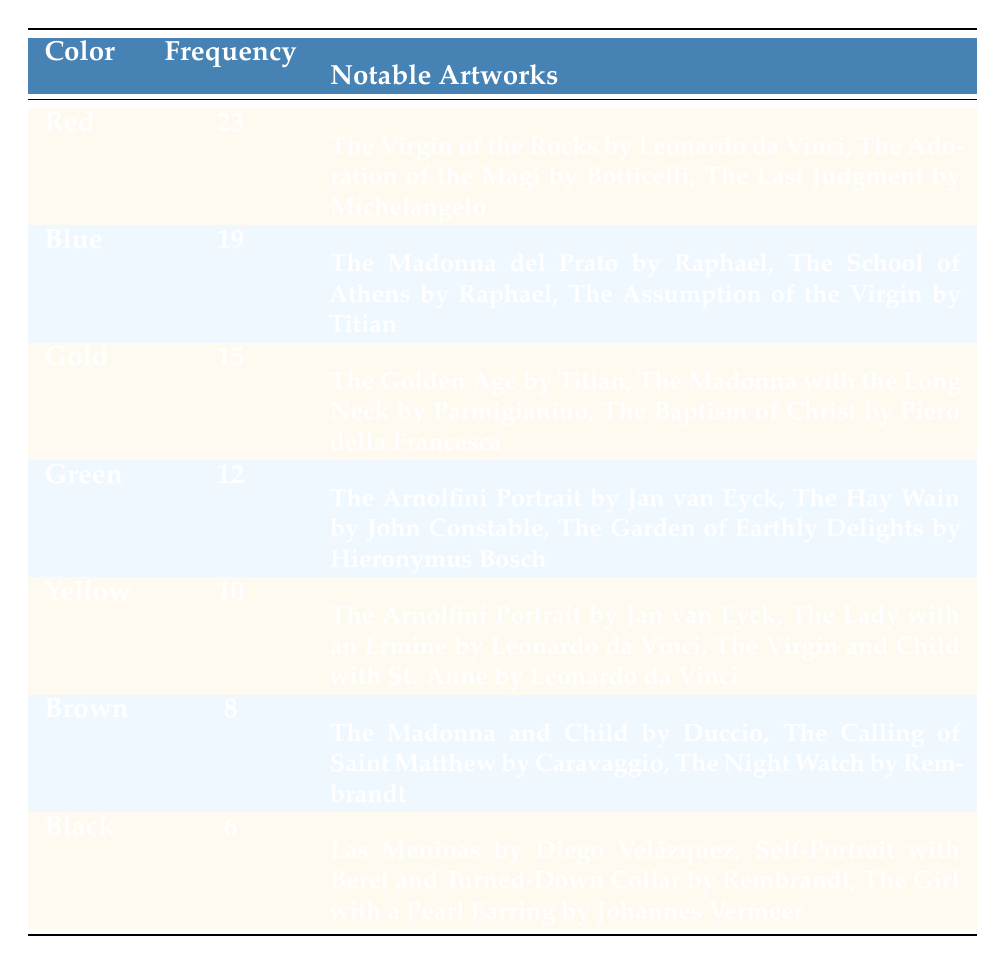What is the frequency of the color Red in the distribution? The frequency of Red is listed directly in the table under the Frequency column, which states it as 23.
Answer: 23 How many notable artworks are associated with the color Blue? The table displays three notable artworks under the color Blue, hence the answer is three.
Answer: 3 What is the total frequency of the color palettes listed in the table? To find the total frequency, we sum up the frequency values: 23 + 19 + 15 + 12 + 10 + 8 + 6 = 93.
Answer: 93 Which color palette has the second highest frequency, and what is its frequency? By examining the frequencies, Red has the highest frequency (23), and Blue has the second highest frequency at 19.
Answer: Blue, 19 True or False: The color Yellow has more notable artworks listed than the color Green. The table shows that Green has three notable artworks while Yellow has three notable artworks as well. Therefore, it is false.
Answer: False What is the difference in frequency between the colors Gold and Brown? The frequency for Gold is 15, and for Brown, it is 8. Thus, the difference is 15 - 8 = 7.
Answer: 7 Which color has fewer notable artworks, Black or Yellow, and what is the difference in their frequencies? Black has three notable artworks, and Yellow also has three notable artworks. Both have a frequency of 6 for Black and 10 for Yellow, so answering which has fewer is relative; the difference in frequencies is 10 - 6 = 4.
Answer: Yellow; 4 Is the frequency of the color Gold greater than the combined frequency of Brown and Black? The frequencies are Gold (15), Brown (8), and Black (6). Combined, Brown and Black total 14 (8 + 6). Since 15 is greater than 14, the statement is true.
Answer: Yes 